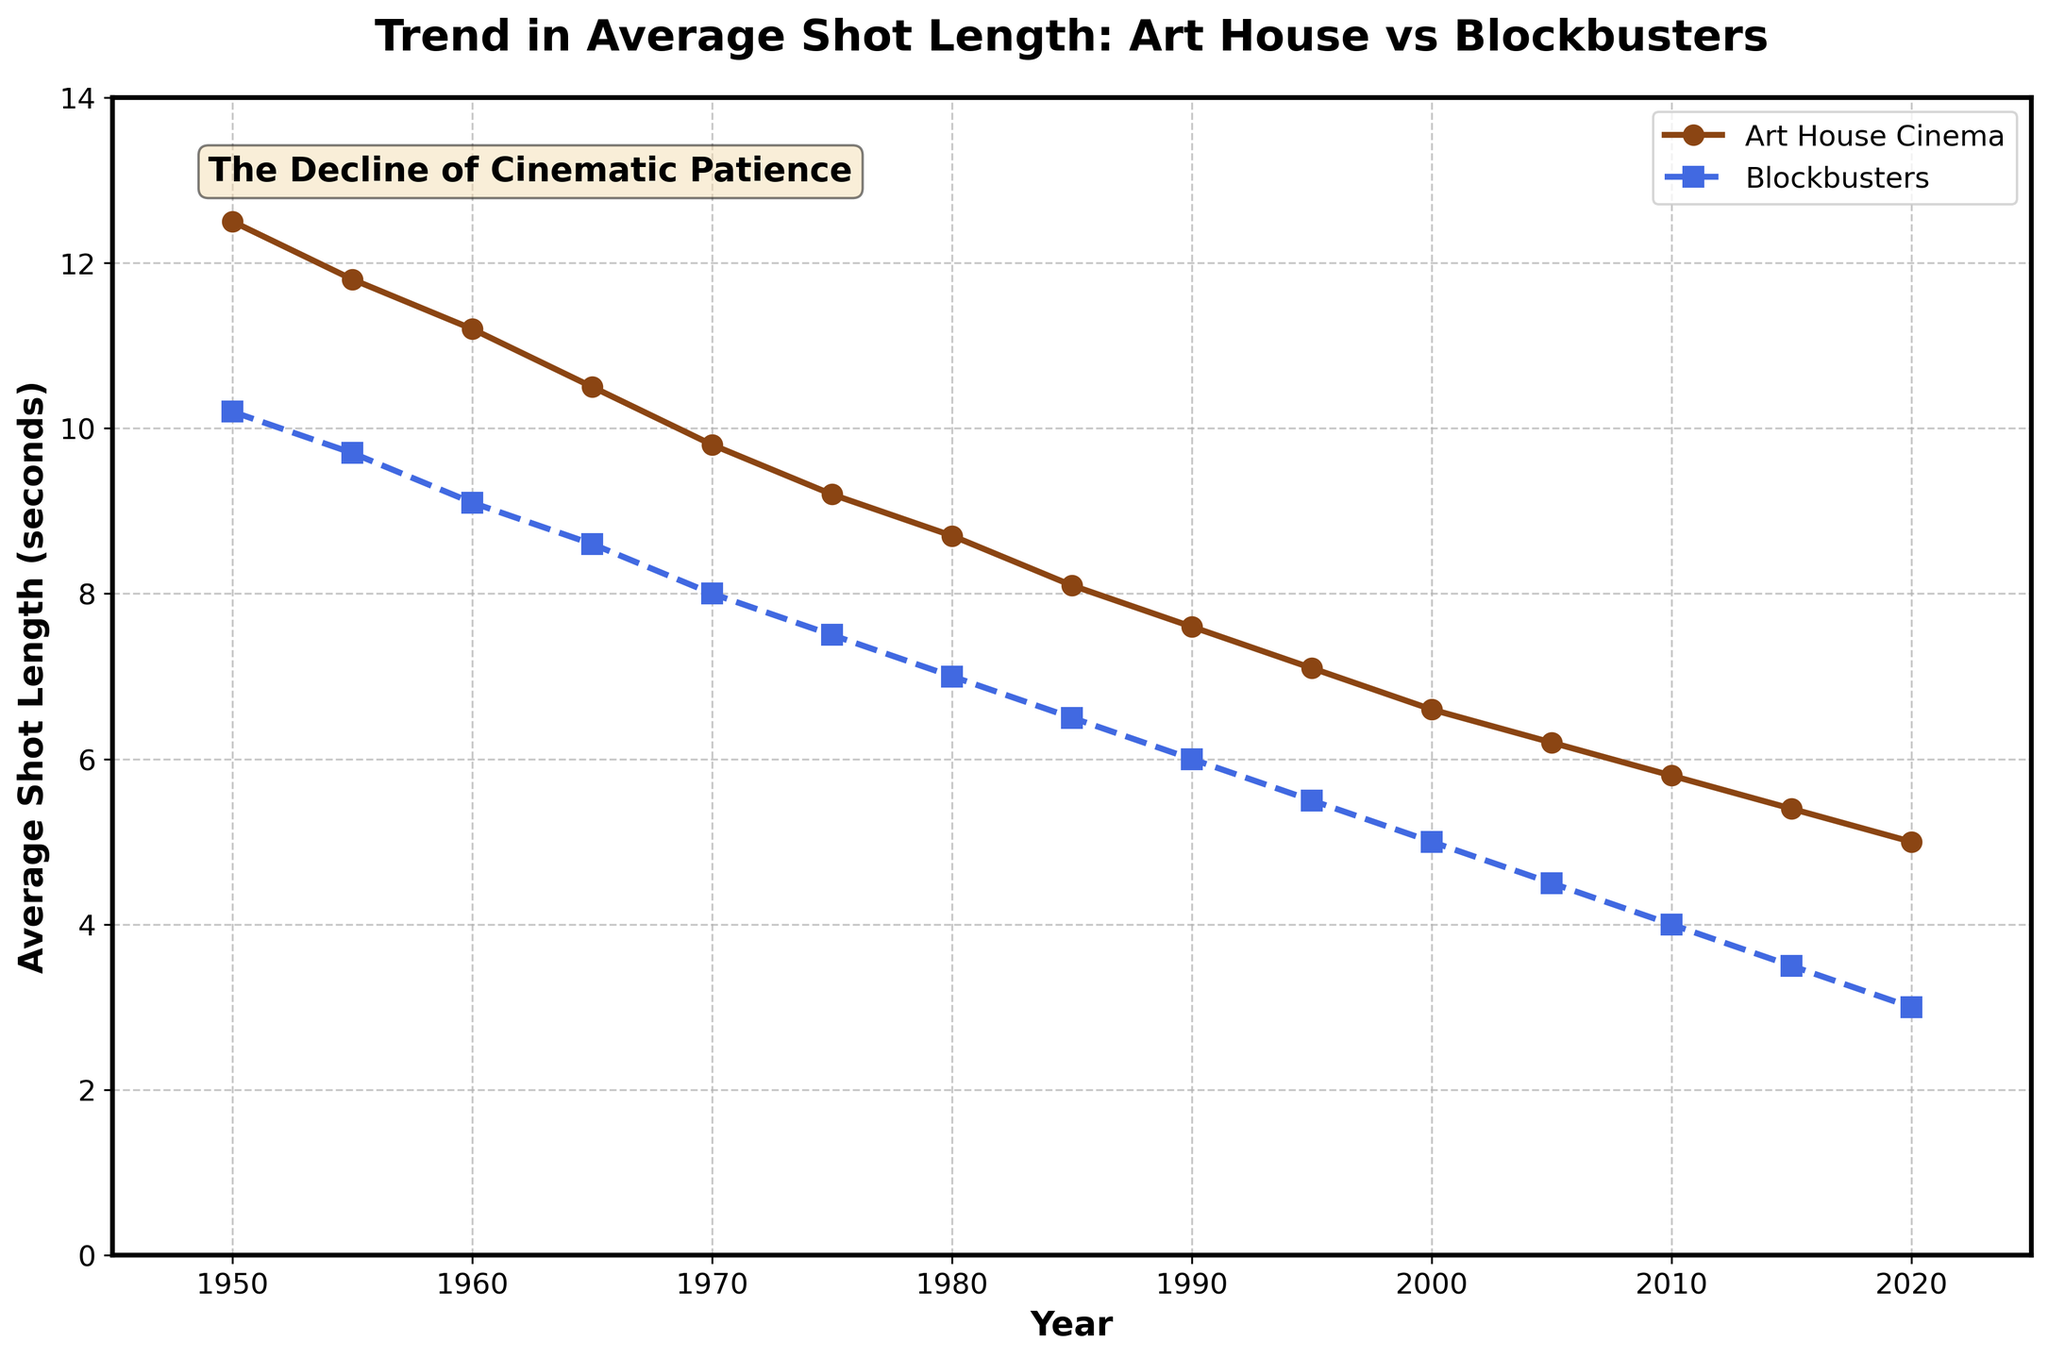What is the overall trend in average shot length for both art house cinema and blockbusters from the 1950s to 2020? Both art house cinema and blockbusters show a consistent decline in average shot length from the 1950s to 2020. For art house cinema, the shot length decreases from around 12.5 seconds to 5 seconds, while for blockbusters, it decreases from 10.2 seconds to 3 seconds.
Answer: Consistent decline Which type of film has consistently shorter average shot lengths, art house cinema or blockbusters, and by how much on average in 2020? Blockbusters consistently have shorter average shot lengths than art house cinema. In 2020, the average shot length for blockbusters is 3 seconds, whereas for art house cinema it is 5 seconds. The difference is 5 - 3 = 2 seconds.
Answer: Blockbusters, by 2 seconds Between which two decades did art house cinema experience the largest decrease in average shot length? By observing the data points on the trend, we can see that the most significant drop appears to occur between the 1960s and the 1970s. The average shot length goes from approximately 11.2 seconds to 9.8 seconds, a decrease of 1.4 seconds.
Answer: 1960s to 1970s In what year did the average shot length of blockbusters fall below 5 seconds for the first time? According to the trend, the average shot length of blockbusters falls below 5 seconds for the first time in 2000 when it reaches 5 seconds exactly and drops further in subsequent years.
Answer: 2005 Which type of film exhibits a more rapid decline in shot length from the 1980s to 2020? To determine the rate of decline, we look at the drop from 1980 to 2020. For art house cinema, this is from 8.7 seconds to 5 seconds (a decline of 3.7 seconds). For blockbusters, it is from 7 seconds to 3 seconds (a decline of 4 seconds). Hence, blockbusters exhibit a more rapid decline.
Answer: Blockbusters How does the average shot length in art house cinema in 1975 compare to the average shot length in blockbusters in 1980? In 1975, the average shot length for art house cinema is 9.2 seconds. For blockbusters in 1980, the average shot length is 7 seconds. So, the shot length for art house cinema in 1975 is longer by 9.2 - 7 = 2.2 seconds.
Answer: Art house cinema in 1975 is 2.2 seconds longer What is the difference in average shot length between art house cinema and blockbusters in 1990? In 1990, the average shot length for art house cinema is 7.6 seconds, and for blockbusters, it is 6 seconds. The difference is 7.6 - 6 = 1.6 seconds.
Answer: 1.6 seconds Based on the trend, if the average shot length continues to decline, what might you predict the average shot length for blockbusters to be in 2025? Extending the linear trend beyond 2020, where the shot length is 3 seconds, we can estimate a further decline of about 0.5 seconds every 5 years. Thus, by 2025, it may drop to around 2.5 seconds.
Answer: 2.5 seconds If you calculate the percentage decrease in average shot length for blockbusters from 1950 to 2020, what will it be? The initial shot length in 1950 is 10.2 seconds and it drops to 3 seconds in 2020. The decrease is 10.2 - 3 = 7.2 seconds. The percentage decrease is (7.2/10.2) * 100 ≈ 70.59%.
Answer: 70.59% Between 2000 and 2020, which type of film experienced a greater absolute reduction in average shot length and by how much? For art house cinema: 6.6 seconds in 2000 to 5 seconds in 2020, a reduction of 1.6 seconds. For blockbusters: 5 seconds in 2000 to 3 seconds in 2020, a reduction of 2 seconds. Blockbusters experienced a greater absolute reduction of 0.4 seconds.
Answer: Blockbusters by 0.4 seconds 